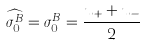Convert formula to latex. <formula><loc_0><loc_0><loc_500><loc_500>\widehat { \sigma _ { 0 } ^ { B } } = \sigma _ { 0 } ^ { B } = \frac { u _ { + } + u _ { - } } { 2 }</formula> 